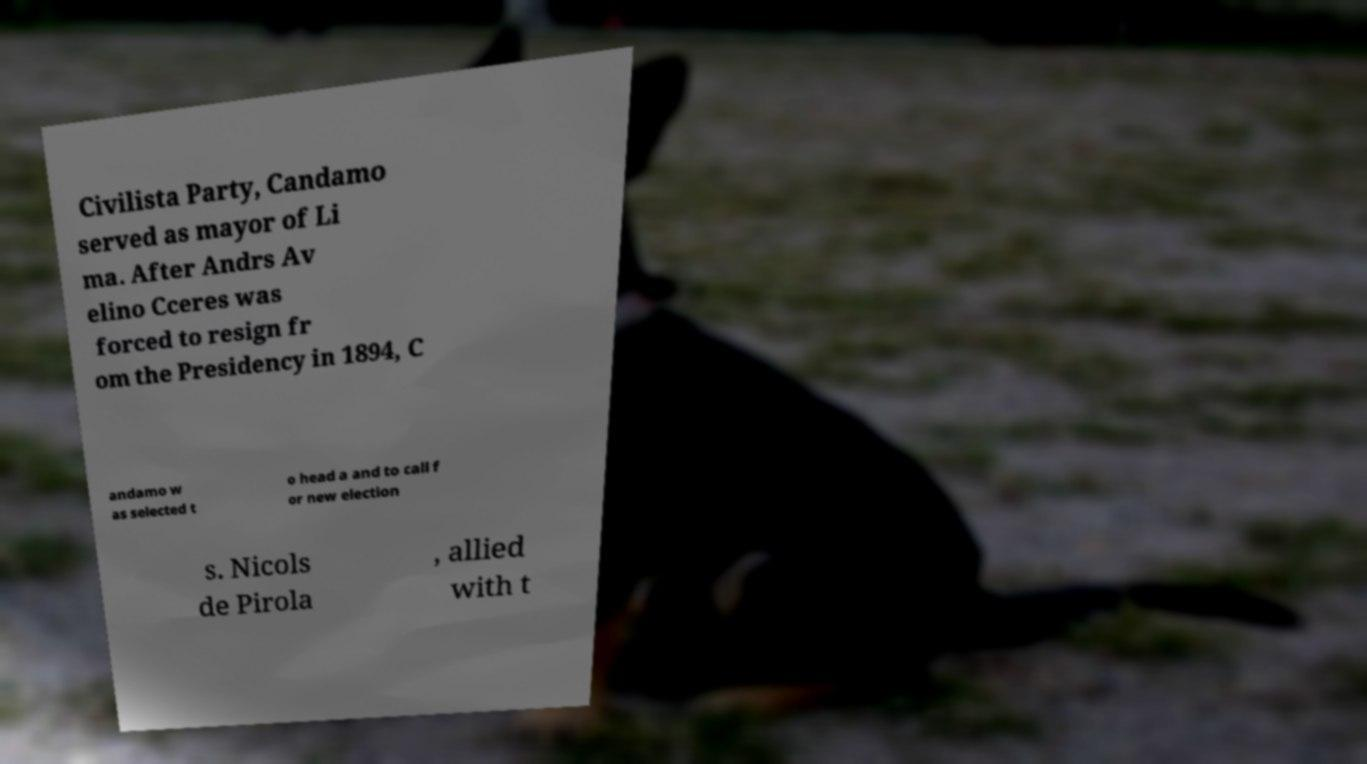What messages or text are displayed in this image? I need them in a readable, typed format. Civilista Party, Candamo served as mayor of Li ma. After Andrs Av elino Cceres was forced to resign fr om the Presidency in 1894, C andamo w as selected t o head a and to call f or new election s. Nicols de Pirola , allied with t 